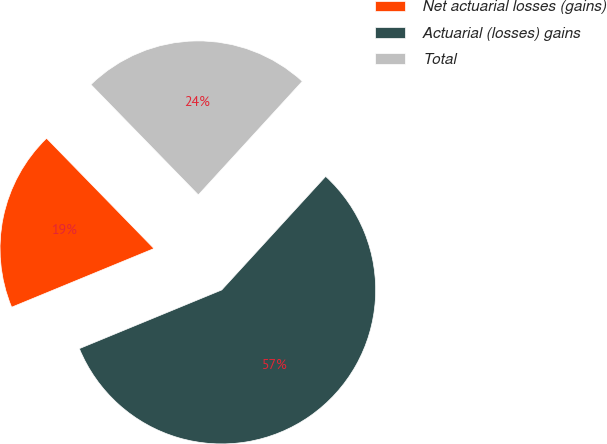Convert chart to OTSL. <chart><loc_0><loc_0><loc_500><loc_500><pie_chart><fcel>Net actuarial losses (gains)<fcel>Actuarial (losses) gains<fcel>Total<nl><fcel>18.93%<fcel>56.98%<fcel>24.09%<nl></chart> 